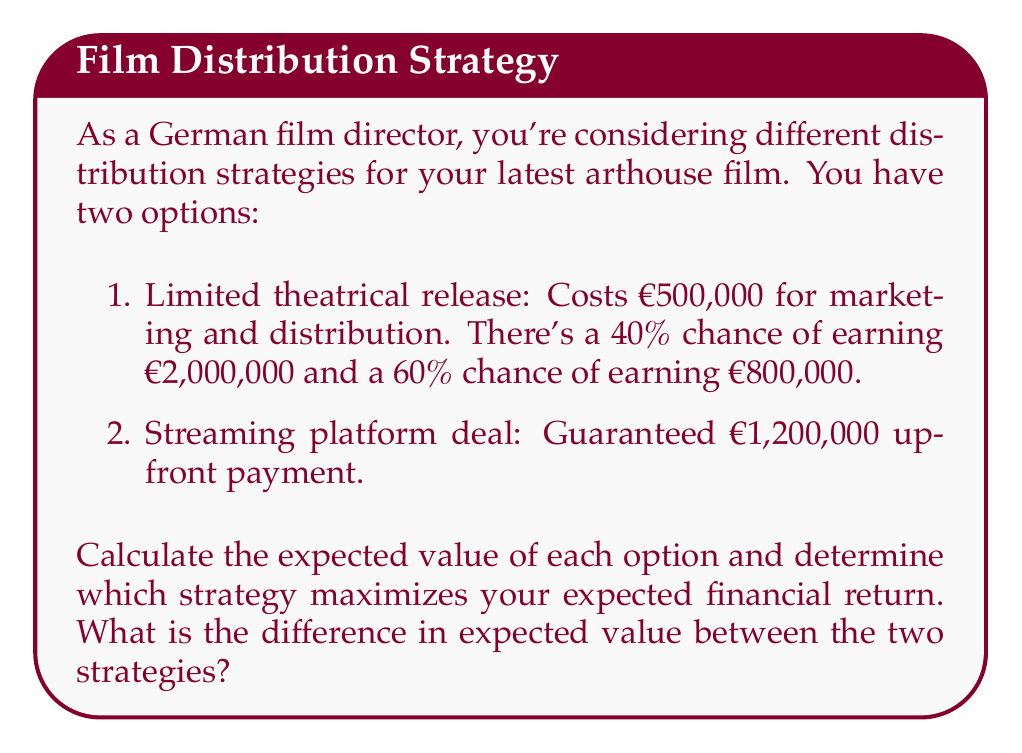Could you help me with this problem? To solve this problem, we need to calculate the expected value for each option and compare them.

1. Limited theatrical release:

Let's calculate the expected revenue:
$$E(\text{Revenue}) = 0.4 \cdot €2,000,000 + 0.6 \cdot €800,000 = €800,000 + €480,000 = €1,280,000$$

Now, we subtract the costs:
$$E(\text{Profit}) = €1,280,000 - €500,000 = €780,000$$

2. Streaming platform deal:

This is a guaranteed amount, so the expected value is simply the upfront payment:
$$E(\text{Profit}) = €1,200,000$$

To determine which strategy maximizes the expected financial return, we compare the two expected values:

$$€1,200,000 > €780,000$$

The streaming platform deal has a higher expected value.

To find the difference in expected value:

$$\text{Difference} = €1,200,000 - €780,000 = €420,000$$
Answer: The streaming platform deal maximizes the expected financial return. The difference in expected value between the two strategies is €420,000. 